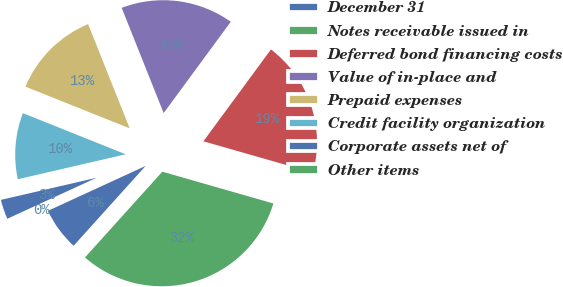Convert chart. <chart><loc_0><loc_0><loc_500><loc_500><pie_chart><fcel>December 31<fcel>Notes receivable issued in<fcel>Deferred bond financing costs<fcel>Value of in-place and<fcel>Prepaid expenses<fcel>Credit facility organization<fcel>Corporate assets net of<fcel>Other items<nl><fcel>6.46%<fcel>32.24%<fcel>19.35%<fcel>16.13%<fcel>12.9%<fcel>9.68%<fcel>3.23%<fcel>0.01%<nl></chart> 